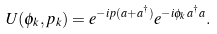Convert formula to latex. <formula><loc_0><loc_0><loc_500><loc_500>U ( \phi _ { k } , p _ { k } ) = e ^ { - i p ( a + a ^ { \dagger } ) } e ^ { - i \phi _ { k } a ^ { \dagger } a } .</formula> 